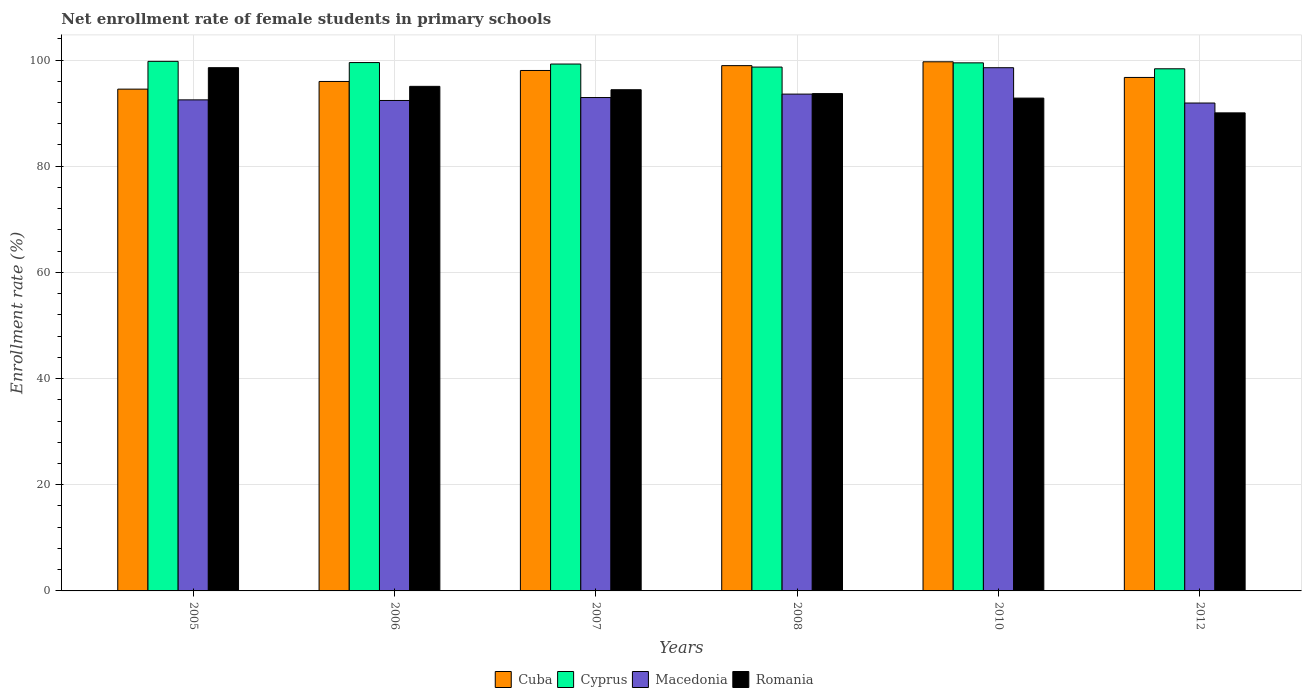How many groups of bars are there?
Offer a terse response. 6. Are the number of bars per tick equal to the number of legend labels?
Your response must be concise. Yes. Are the number of bars on each tick of the X-axis equal?
Your response must be concise. Yes. How many bars are there on the 4th tick from the right?
Your answer should be compact. 4. What is the net enrollment rate of female students in primary schools in Cuba in 2005?
Give a very brief answer. 94.51. Across all years, what is the maximum net enrollment rate of female students in primary schools in Macedonia?
Make the answer very short. 98.55. Across all years, what is the minimum net enrollment rate of female students in primary schools in Macedonia?
Ensure brevity in your answer.  91.9. In which year was the net enrollment rate of female students in primary schools in Macedonia minimum?
Your answer should be compact. 2012. What is the total net enrollment rate of female students in primary schools in Cyprus in the graph?
Offer a terse response. 594.99. What is the difference between the net enrollment rate of female students in primary schools in Macedonia in 2006 and that in 2008?
Your answer should be very brief. -1.2. What is the difference between the net enrollment rate of female students in primary schools in Cyprus in 2008 and the net enrollment rate of female students in primary schools in Romania in 2006?
Provide a short and direct response. 3.63. What is the average net enrollment rate of female students in primary schools in Cyprus per year?
Ensure brevity in your answer.  99.16. In the year 2007, what is the difference between the net enrollment rate of female students in primary schools in Romania and net enrollment rate of female students in primary schools in Cyprus?
Your answer should be compact. -4.84. What is the ratio of the net enrollment rate of female students in primary schools in Cuba in 2006 to that in 2007?
Ensure brevity in your answer.  0.98. Is the net enrollment rate of female students in primary schools in Macedonia in 2005 less than that in 2006?
Give a very brief answer. No. What is the difference between the highest and the second highest net enrollment rate of female students in primary schools in Macedonia?
Your answer should be very brief. 4.97. What is the difference between the highest and the lowest net enrollment rate of female students in primary schools in Cyprus?
Your answer should be very brief. 1.4. Is it the case that in every year, the sum of the net enrollment rate of female students in primary schools in Cyprus and net enrollment rate of female students in primary schools in Romania is greater than the sum of net enrollment rate of female students in primary schools in Cuba and net enrollment rate of female students in primary schools in Macedonia?
Make the answer very short. No. What does the 4th bar from the left in 2012 represents?
Make the answer very short. Romania. What does the 1st bar from the right in 2012 represents?
Provide a short and direct response. Romania. Is it the case that in every year, the sum of the net enrollment rate of female students in primary schools in Cyprus and net enrollment rate of female students in primary schools in Cuba is greater than the net enrollment rate of female students in primary schools in Romania?
Provide a succinct answer. Yes. How many bars are there?
Give a very brief answer. 24. Does the graph contain any zero values?
Your answer should be very brief. No. Does the graph contain grids?
Your answer should be compact. Yes. How are the legend labels stacked?
Your answer should be very brief. Horizontal. What is the title of the graph?
Offer a terse response. Net enrollment rate of female students in primary schools. What is the label or title of the X-axis?
Offer a terse response. Years. What is the label or title of the Y-axis?
Make the answer very short. Enrollment rate (%). What is the Enrollment rate (%) in Cuba in 2005?
Your answer should be very brief. 94.51. What is the Enrollment rate (%) in Cyprus in 2005?
Your response must be concise. 99.75. What is the Enrollment rate (%) in Macedonia in 2005?
Offer a very short reply. 92.49. What is the Enrollment rate (%) in Romania in 2005?
Offer a very short reply. 98.55. What is the Enrollment rate (%) in Cuba in 2006?
Your response must be concise. 95.96. What is the Enrollment rate (%) in Cyprus in 2006?
Give a very brief answer. 99.52. What is the Enrollment rate (%) in Macedonia in 2006?
Provide a short and direct response. 92.38. What is the Enrollment rate (%) of Romania in 2006?
Your answer should be compact. 95.04. What is the Enrollment rate (%) of Cuba in 2007?
Make the answer very short. 98.03. What is the Enrollment rate (%) of Cyprus in 2007?
Provide a succinct answer. 99.24. What is the Enrollment rate (%) in Macedonia in 2007?
Give a very brief answer. 92.93. What is the Enrollment rate (%) of Romania in 2007?
Ensure brevity in your answer.  94.4. What is the Enrollment rate (%) in Cuba in 2008?
Provide a succinct answer. 98.94. What is the Enrollment rate (%) of Cyprus in 2008?
Your answer should be very brief. 98.67. What is the Enrollment rate (%) in Macedonia in 2008?
Provide a succinct answer. 93.58. What is the Enrollment rate (%) in Romania in 2008?
Your answer should be very brief. 93.67. What is the Enrollment rate (%) in Cuba in 2010?
Your response must be concise. 99.66. What is the Enrollment rate (%) in Cyprus in 2010?
Ensure brevity in your answer.  99.46. What is the Enrollment rate (%) in Macedonia in 2010?
Provide a succinct answer. 98.55. What is the Enrollment rate (%) of Romania in 2010?
Provide a short and direct response. 92.82. What is the Enrollment rate (%) in Cuba in 2012?
Provide a short and direct response. 96.72. What is the Enrollment rate (%) of Cyprus in 2012?
Keep it short and to the point. 98.35. What is the Enrollment rate (%) in Macedonia in 2012?
Provide a short and direct response. 91.9. What is the Enrollment rate (%) of Romania in 2012?
Keep it short and to the point. 90.04. Across all years, what is the maximum Enrollment rate (%) in Cuba?
Your response must be concise. 99.66. Across all years, what is the maximum Enrollment rate (%) in Cyprus?
Make the answer very short. 99.75. Across all years, what is the maximum Enrollment rate (%) of Macedonia?
Offer a terse response. 98.55. Across all years, what is the maximum Enrollment rate (%) in Romania?
Keep it short and to the point. 98.55. Across all years, what is the minimum Enrollment rate (%) in Cuba?
Make the answer very short. 94.51. Across all years, what is the minimum Enrollment rate (%) in Cyprus?
Keep it short and to the point. 98.35. Across all years, what is the minimum Enrollment rate (%) in Macedonia?
Provide a short and direct response. 91.9. Across all years, what is the minimum Enrollment rate (%) of Romania?
Provide a succinct answer. 90.04. What is the total Enrollment rate (%) in Cuba in the graph?
Ensure brevity in your answer.  583.82. What is the total Enrollment rate (%) in Cyprus in the graph?
Give a very brief answer. 594.99. What is the total Enrollment rate (%) of Macedonia in the graph?
Ensure brevity in your answer.  561.83. What is the total Enrollment rate (%) of Romania in the graph?
Make the answer very short. 564.54. What is the difference between the Enrollment rate (%) of Cuba in 2005 and that in 2006?
Provide a short and direct response. -1.45. What is the difference between the Enrollment rate (%) in Cyprus in 2005 and that in 2006?
Provide a short and direct response. 0.23. What is the difference between the Enrollment rate (%) in Macedonia in 2005 and that in 2006?
Keep it short and to the point. 0.11. What is the difference between the Enrollment rate (%) of Romania in 2005 and that in 2006?
Give a very brief answer. 3.52. What is the difference between the Enrollment rate (%) in Cuba in 2005 and that in 2007?
Offer a very short reply. -3.51. What is the difference between the Enrollment rate (%) in Cyprus in 2005 and that in 2007?
Your answer should be compact. 0.5. What is the difference between the Enrollment rate (%) of Macedonia in 2005 and that in 2007?
Your answer should be compact. -0.44. What is the difference between the Enrollment rate (%) of Romania in 2005 and that in 2007?
Keep it short and to the point. 4.15. What is the difference between the Enrollment rate (%) in Cuba in 2005 and that in 2008?
Your answer should be very brief. -4.43. What is the difference between the Enrollment rate (%) of Cyprus in 2005 and that in 2008?
Provide a short and direct response. 1.08. What is the difference between the Enrollment rate (%) of Macedonia in 2005 and that in 2008?
Give a very brief answer. -1.09. What is the difference between the Enrollment rate (%) of Romania in 2005 and that in 2008?
Provide a short and direct response. 4.88. What is the difference between the Enrollment rate (%) of Cuba in 2005 and that in 2010?
Offer a terse response. -5.15. What is the difference between the Enrollment rate (%) of Cyprus in 2005 and that in 2010?
Your answer should be very brief. 0.28. What is the difference between the Enrollment rate (%) in Macedonia in 2005 and that in 2010?
Offer a very short reply. -6.06. What is the difference between the Enrollment rate (%) in Romania in 2005 and that in 2010?
Provide a short and direct response. 5.73. What is the difference between the Enrollment rate (%) in Cuba in 2005 and that in 2012?
Your answer should be very brief. -2.2. What is the difference between the Enrollment rate (%) in Cyprus in 2005 and that in 2012?
Your answer should be compact. 1.4. What is the difference between the Enrollment rate (%) of Macedonia in 2005 and that in 2012?
Offer a very short reply. 0.59. What is the difference between the Enrollment rate (%) in Romania in 2005 and that in 2012?
Offer a terse response. 8.51. What is the difference between the Enrollment rate (%) in Cuba in 2006 and that in 2007?
Keep it short and to the point. -2.07. What is the difference between the Enrollment rate (%) of Cyprus in 2006 and that in 2007?
Give a very brief answer. 0.28. What is the difference between the Enrollment rate (%) in Macedonia in 2006 and that in 2007?
Provide a short and direct response. -0.55. What is the difference between the Enrollment rate (%) in Romania in 2006 and that in 2007?
Provide a succinct answer. 0.64. What is the difference between the Enrollment rate (%) in Cuba in 2006 and that in 2008?
Provide a succinct answer. -2.98. What is the difference between the Enrollment rate (%) of Cyprus in 2006 and that in 2008?
Your answer should be compact. 0.85. What is the difference between the Enrollment rate (%) in Macedonia in 2006 and that in 2008?
Your response must be concise. -1.2. What is the difference between the Enrollment rate (%) in Romania in 2006 and that in 2008?
Give a very brief answer. 1.36. What is the difference between the Enrollment rate (%) in Cuba in 2006 and that in 2010?
Give a very brief answer. -3.7. What is the difference between the Enrollment rate (%) of Cyprus in 2006 and that in 2010?
Give a very brief answer. 0.05. What is the difference between the Enrollment rate (%) in Macedonia in 2006 and that in 2010?
Offer a very short reply. -6.17. What is the difference between the Enrollment rate (%) in Romania in 2006 and that in 2010?
Give a very brief answer. 2.21. What is the difference between the Enrollment rate (%) in Cuba in 2006 and that in 2012?
Provide a short and direct response. -0.76. What is the difference between the Enrollment rate (%) of Cyprus in 2006 and that in 2012?
Make the answer very short. 1.17. What is the difference between the Enrollment rate (%) in Macedonia in 2006 and that in 2012?
Offer a terse response. 0.48. What is the difference between the Enrollment rate (%) in Romania in 2006 and that in 2012?
Your response must be concise. 5. What is the difference between the Enrollment rate (%) in Cuba in 2007 and that in 2008?
Provide a succinct answer. -0.91. What is the difference between the Enrollment rate (%) in Cyprus in 2007 and that in 2008?
Your answer should be compact. 0.57. What is the difference between the Enrollment rate (%) in Macedonia in 2007 and that in 2008?
Your answer should be compact. -0.65. What is the difference between the Enrollment rate (%) of Romania in 2007 and that in 2008?
Provide a short and direct response. 0.73. What is the difference between the Enrollment rate (%) of Cuba in 2007 and that in 2010?
Provide a short and direct response. -1.64. What is the difference between the Enrollment rate (%) of Cyprus in 2007 and that in 2010?
Provide a short and direct response. -0.22. What is the difference between the Enrollment rate (%) in Macedonia in 2007 and that in 2010?
Provide a short and direct response. -5.62. What is the difference between the Enrollment rate (%) in Romania in 2007 and that in 2010?
Your answer should be compact. 1.58. What is the difference between the Enrollment rate (%) of Cuba in 2007 and that in 2012?
Make the answer very short. 1.31. What is the difference between the Enrollment rate (%) of Cyprus in 2007 and that in 2012?
Ensure brevity in your answer.  0.9. What is the difference between the Enrollment rate (%) of Macedonia in 2007 and that in 2012?
Give a very brief answer. 1.03. What is the difference between the Enrollment rate (%) of Romania in 2007 and that in 2012?
Give a very brief answer. 4.36. What is the difference between the Enrollment rate (%) in Cuba in 2008 and that in 2010?
Offer a terse response. -0.72. What is the difference between the Enrollment rate (%) in Cyprus in 2008 and that in 2010?
Provide a succinct answer. -0.8. What is the difference between the Enrollment rate (%) in Macedonia in 2008 and that in 2010?
Your response must be concise. -4.97. What is the difference between the Enrollment rate (%) of Romania in 2008 and that in 2010?
Your answer should be very brief. 0.85. What is the difference between the Enrollment rate (%) in Cuba in 2008 and that in 2012?
Your response must be concise. 2.22. What is the difference between the Enrollment rate (%) in Cyprus in 2008 and that in 2012?
Provide a short and direct response. 0.32. What is the difference between the Enrollment rate (%) in Macedonia in 2008 and that in 2012?
Offer a very short reply. 1.68. What is the difference between the Enrollment rate (%) of Romania in 2008 and that in 2012?
Ensure brevity in your answer.  3.63. What is the difference between the Enrollment rate (%) of Cuba in 2010 and that in 2012?
Offer a very short reply. 2.95. What is the difference between the Enrollment rate (%) in Cyprus in 2010 and that in 2012?
Your answer should be very brief. 1.12. What is the difference between the Enrollment rate (%) in Macedonia in 2010 and that in 2012?
Provide a short and direct response. 6.65. What is the difference between the Enrollment rate (%) in Romania in 2010 and that in 2012?
Your response must be concise. 2.78. What is the difference between the Enrollment rate (%) of Cuba in 2005 and the Enrollment rate (%) of Cyprus in 2006?
Provide a short and direct response. -5. What is the difference between the Enrollment rate (%) in Cuba in 2005 and the Enrollment rate (%) in Macedonia in 2006?
Offer a very short reply. 2.13. What is the difference between the Enrollment rate (%) of Cuba in 2005 and the Enrollment rate (%) of Romania in 2006?
Your response must be concise. -0.53. What is the difference between the Enrollment rate (%) of Cyprus in 2005 and the Enrollment rate (%) of Macedonia in 2006?
Offer a very short reply. 7.37. What is the difference between the Enrollment rate (%) in Cyprus in 2005 and the Enrollment rate (%) in Romania in 2006?
Offer a terse response. 4.71. What is the difference between the Enrollment rate (%) in Macedonia in 2005 and the Enrollment rate (%) in Romania in 2006?
Your response must be concise. -2.55. What is the difference between the Enrollment rate (%) of Cuba in 2005 and the Enrollment rate (%) of Cyprus in 2007?
Offer a very short reply. -4.73. What is the difference between the Enrollment rate (%) of Cuba in 2005 and the Enrollment rate (%) of Macedonia in 2007?
Your response must be concise. 1.58. What is the difference between the Enrollment rate (%) in Cuba in 2005 and the Enrollment rate (%) in Romania in 2007?
Provide a short and direct response. 0.11. What is the difference between the Enrollment rate (%) in Cyprus in 2005 and the Enrollment rate (%) in Macedonia in 2007?
Give a very brief answer. 6.82. What is the difference between the Enrollment rate (%) in Cyprus in 2005 and the Enrollment rate (%) in Romania in 2007?
Ensure brevity in your answer.  5.35. What is the difference between the Enrollment rate (%) of Macedonia in 2005 and the Enrollment rate (%) of Romania in 2007?
Provide a short and direct response. -1.91. What is the difference between the Enrollment rate (%) of Cuba in 2005 and the Enrollment rate (%) of Cyprus in 2008?
Offer a very short reply. -4.16. What is the difference between the Enrollment rate (%) in Cuba in 2005 and the Enrollment rate (%) in Macedonia in 2008?
Your answer should be very brief. 0.93. What is the difference between the Enrollment rate (%) of Cuba in 2005 and the Enrollment rate (%) of Romania in 2008?
Your answer should be compact. 0.84. What is the difference between the Enrollment rate (%) of Cyprus in 2005 and the Enrollment rate (%) of Macedonia in 2008?
Provide a short and direct response. 6.17. What is the difference between the Enrollment rate (%) in Cyprus in 2005 and the Enrollment rate (%) in Romania in 2008?
Provide a short and direct response. 6.07. What is the difference between the Enrollment rate (%) of Macedonia in 2005 and the Enrollment rate (%) of Romania in 2008?
Ensure brevity in your answer.  -1.18. What is the difference between the Enrollment rate (%) of Cuba in 2005 and the Enrollment rate (%) of Cyprus in 2010?
Make the answer very short. -4.95. What is the difference between the Enrollment rate (%) in Cuba in 2005 and the Enrollment rate (%) in Macedonia in 2010?
Give a very brief answer. -4.04. What is the difference between the Enrollment rate (%) of Cuba in 2005 and the Enrollment rate (%) of Romania in 2010?
Your answer should be compact. 1.69. What is the difference between the Enrollment rate (%) in Cyprus in 2005 and the Enrollment rate (%) in Macedonia in 2010?
Give a very brief answer. 1.2. What is the difference between the Enrollment rate (%) of Cyprus in 2005 and the Enrollment rate (%) of Romania in 2010?
Your answer should be very brief. 6.92. What is the difference between the Enrollment rate (%) of Macedonia in 2005 and the Enrollment rate (%) of Romania in 2010?
Give a very brief answer. -0.33. What is the difference between the Enrollment rate (%) of Cuba in 2005 and the Enrollment rate (%) of Cyprus in 2012?
Provide a short and direct response. -3.83. What is the difference between the Enrollment rate (%) in Cuba in 2005 and the Enrollment rate (%) in Macedonia in 2012?
Make the answer very short. 2.62. What is the difference between the Enrollment rate (%) of Cuba in 2005 and the Enrollment rate (%) of Romania in 2012?
Keep it short and to the point. 4.47. What is the difference between the Enrollment rate (%) of Cyprus in 2005 and the Enrollment rate (%) of Macedonia in 2012?
Make the answer very short. 7.85. What is the difference between the Enrollment rate (%) of Cyprus in 2005 and the Enrollment rate (%) of Romania in 2012?
Give a very brief answer. 9.7. What is the difference between the Enrollment rate (%) of Macedonia in 2005 and the Enrollment rate (%) of Romania in 2012?
Give a very brief answer. 2.45. What is the difference between the Enrollment rate (%) in Cuba in 2006 and the Enrollment rate (%) in Cyprus in 2007?
Provide a succinct answer. -3.28. What is the difference between the Enrollment rate (%) of Cuba in 2006 and the Enrollment rate (%) of Macedonia in 2007?
Your answer should be very brief. 3.03. What is the difference between the Enrollment rate (%) of Cuba in 2006 and the Enrollment rate (%) of Romania in 2007?
Your answer should be compact. 1.56. What is the difference between the Enrollment rate (%) in Cyprus in 2006 and the Enrollment rate (%) in Macedonia in 2007?
Ensure brevity in your answer.  6.59. What is the difference between the Enrollment rate (%) in Cyprus in 2006 and the Enrollment rate (%) in Romania in 2007?
Your answer should be compact. 5.12. What is the difference between the Enrollment rate (%) in Macedonia in 2006 and the Enrollment rate (%) in Romania in 2007?
Your response must be concise. -2.02. What is the difference between the Enrollment rate (%) of Cuba in 2006 and the Enrollment rate (%) of Cyprus in 2008?
Give a very brief answer. -2.71. What is the difference between the Enrollment rate (%) in Cuba in 2006 and the Enrollment rate (%) in Macedonia in 2008?
Your answer should be compact. 2.38. What is the difference between the Enrollment rate (%) in Cuba in 2006 and the Enrollment rate (%) in Romania in 2008?
Make the answer very short. 2.29. What is the difference between the Enrollment rate (%) in Cyprus in 2006 and the Enrollment rate (%) in Macedonia in 2008?
Provide a succinct answer. 5.94. What is the difference between the Enrollment rate (%) in Cyprus in 2006 and the Enrollment rate (%) in Romania in 2008?
Provide a short and direct response. 5.84. What is the difference between the Enrollment rate (%) in Macedonia in 2006 and the Enrollment rate (%) in Romania in 2008?
Keep it short and to the point. -1.3. What is the difference between the Enrollment rate (%) in Cuba in 2006 and the Enrollment rate (%) in Cyprus in 2010?
Provide a short and direct response. -3.51. What is the difference between the Enrollment rate (%) in Cuba in 2006 and the Enrollment rate (%) in Macedonia in 2010?
Offer a very short reply. -2.59. What is the difference between the Enrollment rate (%) in Cuba in 2006 and the Enrollment rate (%) in Romania in 2010?
Give a very brief answer. 3.14. What is the difference between the Enrollment rate (%) in Cyprus in 2006 and the Enrollment rate (%) in Macedonia in 2010?
Your answer should be compact. 0.97. What is the difference between the Enrollment rate (%) in Cyprus in 2006 and the Enrollment rate (%) in Romania in 2010?
Ensure brevity in your answer.  6.69. What is the difference between the Enrollment rate (%) in Macedonia in 2006 and the Enrollment rate (%) in Romania in 2010?
Your answer should be compact. -0.45. What is the difference between the Enrollment rate (%) in Cuba in 2006 and the Enrollment rate (%) in Cyprus in 2012?
Ensure brevity in your answer.  -2.39. What is the difference between the Enrollment rate (%) in Cuba in 2006 and the Enrollment rate (%) in Macedonia in 2012?
Offer a very short reply. 4.06. What is the difference between the Enrollment rate (%) of Cuba in 2006 and the Enrollment rate (%) of Romania in 2012?
Your answer should be very brief. 5.92. What is the difference between the Enrollment rate (%) of Cyprus in 2006 and the Enrollment rate (%) of Macedonia in 2012?
Your answer should be very brief. 7.62. What is the difference between the Enrollment rate (%) in Cyprus in 2006 and the Enrollment rate (%) in Romania in 2012?
Provide a short and direct response. 9.47. What is the difference between the Enrollment rate (%) of Macedonia in 2006 and the Enrollment rate (%) of Romania in 2012?
Ensure brevity in your answer.  2.33. What is the difference between the Enrollment rate (%) in Cuba in 2007 and the Enrollment rate (%) in Cyprus in 2008?
Provide a short and direct response. -0.64. What is the difference between the Enrollment rate (%) of Cuba in 2007 and the Enrollment rate (%) of Macedonia in 2008?
Offer a very short reply. 4.45. What is the difference between the Enrollment rate (%) in Cuba in 2007 and the Enrollment rate (%) in Romania in 2008?
Your answer should be very brief. 4.35. What is the difference between the Enrollment rate (%) in Cyprus in 2007 and the Enrollment rate (%) in Macedonia in 2008?
Your answer should be very brief. 5.66. What is the difference between the Enrollment rate (%) of Cyprus in 2007 and the Enrollment rate (%) of Romania in 2008?
Keep it short and to the point. 5.57. What is the difference between the Enrollment rate (%) in Macedonia in 2007 and the Enrollment rate (%) in Romania in 2008?
Give a very brief answer. -0.74. What is the difference between the Enrollment rate (%) in Cuba in 2007 and the Enrollment rate (%) in Cyprus in 2010?
Your response must be concise. -1.44. What is the difference between the Enrollment rate (%) in Cuba in 2007 and the Enrollment rate (%) in Macedonia in 2010?
Your response must be concise. -0.52. What is the difference between the Enrollment rate (%) of Cuba in 2007 and the Enrollment rate (%) of Romania in 2010?
Offer a terse response. 5.2. What is the difference between the Enrollment rate (%) in Cyprus in 2007 and the Enrollment rate (%) in Macedonia in 2010?
Keep it short and to the point. 0.69. What is the difference between the Enrollment rate (%) of Cyprus in 2007 and the Enrollment rate (%) of Romania in 2010?
Offer a very short reply. 6.42. What is the difference between the Enrollment rate (%) in Macedonia in 2007 and the Enrollment rate (%) in Romania in 2010?
Keep it short and to the point. 0.11. What is the difference between the Enrollment rate (%) of Cuba in 2007 and the Enrollment rate (%) of Cyprus in 2012?
Keep it short and to the point. -0.32. What is the difference between the Enrollment rate (%) of Cuba in 2007 and the Enrollment rate (%) of Macedonia in 2012?
Make the answer very short. 6.13. What is the difference between the Enrollment rate (%) of Cuba in 2007 and the Enrollment rate (%) of Romania in 2012?
Keep it short and to the point. 7.98. What is the difference between the Enrollment rate (%) of Cyprus in 2007 and the Enrollment rate (%) of Macedonia in 2012?
Your answer should be compact. 7.34. What is the difference between the Enrollment rate (%) of Cyprus in 2007 and the Enrollment rate (%) of Romania in 2012?
Provide a short and direct response. 9.2. What is the difference between the Enrollment rate (%) of Macedonia in 2007 and the Enrollment rate (%) of Romania in 2012?
Give a very brief answer. 2.89. What is the difference between the Enrollment rate (%) in Cuba in 2008 and the Enrollment rate (%) in Cyprus in 2010?
Ensure brevity in your answer.  -0.52. What is the difference between the Enrollment rate (%) of Cuba in 2008 and the Enrollment rate (%) of Macedonia in 2010?
Provide a succinct answer. 0.39. What is the difference between the Enrollment rate (%) in Cuba in 2008 and the Enrollment rate (%) in Romania in 2010?
Provide a short and direct response. 6.12. What is the difference between the Enrollment rate (%) in Cyprus in 2008 and the Enrollment rate (%) in Macedonia in 2010?
Your answer should be compact. 0.12. What is the difference between the Enrollment rate (%) of Cyprus in 2008 and the Enrollment rate (%) of Romania in 2010?
Make the answer very short. 5.85. What is the difference between the Enrollment rate (%) of Macedonia in 2008 and the Enrollment rate (%) of Romania in 2010?
Provide a short and direct response. 0.75. What is the difference between the Enrollment rate (%) in Cuba in 2008 and the Enrollment rate (%) in Cyprus in 2012?
Your answer should be very brief. 0.59. What is the difference between the Enrollment rate (%) of Cuba in 2008 and the Enrollment rate (%) of Macedonia in 2012?
Keep it short and to the point. 7.04. What is the difference between the Enrollment rate (%) of Cuba in 2008 and the Enrollment rate (%) of Romania in 2012?
Provide a succinct answer. 8.9. What is the difference between the Enrollment rate (%) in Cyprus in 2008 and the Enrollment rate (%) in Macedonia in 2012?
Provide a short and direct response. 6.77. What is the difference between the Enrollment rate (%) of Cyprus in 2008 and the Enrollment rate (%) of Romania in 2012?
Provide a succinct answer. 8.63. What is the difference between the Enrollment rate (%) in Macedonia in 2008 and the Enrollment rate (%) in Romania in 2012?
Your answer should be very brief. 3.54. What is the difference between the Enrollment rate (%) of Cuba in 2010 and the Enrollment rate (%) of Cyprus in 2012?
Your answer should be very brief. 1.32. What is the difference between the Enrollment rate (%) in Cuba in 2010 and the Enrollment rate (%) in Macedonia in 2012?
Give a very brief answer. 7.77. What is the difference between the Enrollment rate (%) in Cuba in 2010 and the Enrollment rate (%) in Romania in 2012?
Offer a very short reply. 9.62. What is the difference between the Enrollment rate (%) of Cyprus in 2010 and the Enrollment rate (%) of Macedonia in 2012?
Your answer should be very brief. 7.57. What is the difference between the Enrollment rate (%) of Cyprus in 2010 and the Enrollment rate (%) of Romania in 2012?
Keep it short and to the point. 9.42. What is the difference between the Enrollment rate (%) in Macedonia in 2010 and the Enrollment rate (%) in Romania in 2012?
Offer a terse response. 8.5. What is the average Enrollment rate (%) of Cuba per year?
Your response must be concise. 97.3. What is the average Enrollment rate (%) in Cyprus per year?
Offer a very short reply. 99.16. What is the average Enrollment rate (%) in Macedonia per year?
Ensure brevity in your answer.  93.64. What is the average Enrollment rate (%) of Romania per year?
Provide a short and direct response. 94.09. In the year 2005, what is the difference between the Enrollment rate (%) of Cuba and Enrollment rate (%) of Cyprus?
Give a very brief answer. -5.23. In the year 2005, what is the difference between the Enrollment rate (%) of Cuba and Enrollment rate (%) of Macedonia?
Keep it short and to the point. 2.02. In the year 2005, what is the difference between the Enrollment rate (%) of Cuba and Enrollment rate (%) of Romania?
Your answer should be compact. -4.04. In the year 2005, what is the difference between the Enrollment rate (%) of Cyprus and Enrollment rate (%) of Macedonia?
Ensure brevity in your answer.  7.25. In the year 2005, what is the difference between the Enrollment rate (%) in Cyprus and Enrollment rate (%) in Romania?
Offer a terse response. 1.19. In the year 2005, what is the difference between the Enrollment rate (%) of Macedonia and Enrollment rate (%) of Romania?
Your answer should be compact. -6.06. In the year 2006, what is the difference between the Enrollment rate (%) of Cuba and Enrollment rate (%) of Cyprus?
Your answer should be very brief. -3.56. In the year 2006, what is the difference between the Enrollment rate (%) of Cuba and Enrollment rate (%) of Macedonia?
Your response must be concise. 3.58. In the year 2006, what is the difference between the Enrollment rate (%) of Cuba and Enrollment rate (%) of Romania?
Give a very brief answer. 0.92. In the year 2006, what is the difference between the Enrollment rate (%) in Cyprus and Enrollment rate (%) in Macedonia?
Keep it short and to the point. 7.14. In the year 2006, what is the difference between the Enrollment rate (%) of Cyprus and Enrollment rate (%) of Romania?
Your answer should be compact. 4.48. In the year 2006, what is the difference between the Enrollment rate (%) in Macedonia and Enrollment rate (%) in Romania?
Your answer should be compact. -2.66. In the year 2007, what is the difference between the Enrollment rate (%) of Cuba and Enrollment rate (%) of Cyprus?
Your response must be concise. -1.21. In the year 2007, what is the difference between the Enrollment rate (%) of Cuba and Enrollment rate (%) of Macedonia?
Ensure brevity in your answer.  5.1. In the year 2007, what is the difference between the Enrollment rate (%) of Cuba and Enrollment rate (%) of Romania?
Provide a short and direct response. 3.63. In the year 2007, what is the difference between the Enrollment rate (%) in Cyprus and Enrollment rate (%) in Macedonia?
Provide a succinct answer. 6.31. In the year 2007, what is the difference between the Enrollment rate (%) in Cyprus and Enrollment rate (%) in Romania?
Ensure brevity in your answer.  4.84. In the year 2007, what is the difference between the Enrollment rate (%) in Macedonia and Enrollment rate (%) in Romania?
Make the answer very short. -1.47. In the year 2008, what is the difference between the Enrollment rate (%) in Cuba and Enrollment rate (%) in Cyprus?
Your answer should be very brief. 0.27. In the year 2008, what is the difference between the Enrollment rate (%) in Cuba and Enrollment rate (%) in Macedonia?
Your response must be concise. 5.36. In the year 2008, what is the difference between the Enrollment rate (%) of Cuba and Enrollment rate (%) of Romania?
Your response must be concise. 5.27. In the year 2008, what is the difference between the Enrollment rate (%) of Cyprus and Enrollment rate (%) of Macedonia?
Make the answer very short. 5.09. In the year 2008, what is the difference between the Enrollment rate (%) of Cyprus and Enrollment rate (%) of Romania?
Provide a short and direct response. 5. In the year 2008, what is the difference between the Enrollment rate (%) in Macedonia and Enrollment rate (%) in Romania?
Your response must be concise. -0.1. In the year 2010, what is the difference between the Enrollment rate (%) of Cuba and Enrollment rate (%) of Cyprus?
Your response must be concise. 0.2. In the year 2010, what is the difference between the Enrollment rate (%) in Cuba and Enrollment rate (%) in Macedonia?
Provide a short and direct response. 1.12. In the year 2010, what is the difference between the Enrollment rate (%) of Cuba and Enrollment rate (%) of Romania?
Provide a short and direct response. 6.84. In the year 2010, what is the difference between the Enrollment rate (%) in Cyprus and Enrollment rate (%) in Macedonia?
Offer a very short reply. 0.92. In the year 2010, what is the difference between the Enrollment rate (%) in Cyprus and Enrollment rate (%) in Romania?
Your response must be concise. 6.64. In the year 2010, what is the difference between the Enrollment rate (%) in Macedonia and Enrollment rate (%) in Romania?
Your response must be concise. 5.72. In the year 2012, what is the difference between the Enrollment rate (%) in Cuba and Enrollment rate (%) in Cyprus?
Your answer should be compact. -1.63. In the year 2012, what is the difference between the Enrollment rate (%) in Cuba and Enrollment rate (%) in Macedonia?
Your answer should be very brief. 4.82. In the year 2012, what is the difference between the Enrollment rate (%) in Cuba and Enrollment rate (%) in Romania?
Provide a short and direct response. 6.67. In the year 2012, what is the difference between the Enrollment rate (%) of Cyprus and Enrollment rate (%) of Macedonia?
Provide a succinct answer. 6.45. In the year 2012, what is the difference between the Enrollment rate (%) of Cyprus and Enrollment rate (%) of Romania?
Your answer should be very brief. 8.3. In the year 2012, what is the difference between the Enrollment rate (%) of Macedonia and Enrollment rate (%) of Romania?
Offer a terse response. 1.85. What is the ratio of the Enrollment rate (%) in Cuba in 2005 to that in 2006?
Make the answer very short. 0.98. What is the ratio of the Enrollment rate (%) of Cyprus in 2005 to that in 2006?
Provide a short and direct response. 1. What is the ratio of the Enrollment rate (%) in Macedonia in 2005 to that in 2006?
Offer a very short reply. 1. What is the ratio of the Enrollment rate (%) in Romania in 2005 to that in 2006?
Your answer should be very brief. 1.04. What is the ratio of the Enrollment rate (%) in Cuba in 2005 to that in 2007?
Offer a terse response. 0.96. What is the ratio of the Enrollment rate (%) of Macedonia in 2005 to that in 2007?
Ensure brevity in your answer.  1. What is the ratio of the Enrollment rate (%) of Romania in 2005 to that in 2007?
Your response must be concise. 1.04. What is the ratio of the Enrollment rate (%) in Cuba in 2005 to that in 2008?
Give a very brief answer. 0.96. What is the ratio of the Enrollment rate (%) of Cyprus in 2005 to that in 2008?
Your answer should be compact. 1.01. What is the ratio of the Enrollment rate (%) of Macedonia in 2005 to that in 2008?
Your response must be concise. 0.99. What is the ratio of the Enrollment rate (%) in Romania in 2005 to that in 2008?
Give a very brief answer. 1.05. What is the ratio of the Enrollment rate (%) in Cuba in 2005 to that in 2010?
Your answer should be compact. 0.95. What is the ratio of the Enrollment rate (%) in Cyprus in 2005 to that in 2010?
Give a very brief answer. 1. What is the ratio of the Enrollment rate (%) in Macedonia in 2005 to that in 2010?
Offer a terse response. 0.94. What is the ratio of the Enrollment rate (%) of Romania in 2005 to that in 2010?
Offer a very short reply. 1.06. What is the ratio of the Enrollment rate (%) of Cuba in 2005 to that in 2012?
Provide a succinct answer. 0.98. What is the ratio of the Enrollment rate (%) in Cyprus in 2005 to that in 2012?
Your answer should be very brief. 1.01. What is the ratio of the Enrollment rate (%) in Romania in 2005 to that in 2012?
Keep it short and to the point. 1.09. What is the ratio of the Enrollment rate (%) of Cuba in 2006 to that in 2007?
Give a very brief answer. 0.98. What is the ratio of the Enrollment rate (%) of Cyprus in 2006 to that in 2007?
Your response must be concise. 1. What is the ratio of the Enrollment rate (%) in Macedonia in 2006 to that in 2007?
Offer a terse response. 0.99. What is the ratio of the Enrollment rate (%) of Romania in 2006 to that in 2007?
Ensure brevity in your answer.  1.01. What is the ratio of the Enrollment rate (%) of Cuba in 2006 to that in 2008?
Your response must be concise. 0.97. What is the ratio of the Enrollment rate (%) of Cyprus in 2006 to that in 2008?
Give a very brief answer. 1.01. What is the ratio of the Enrollment rate (%) in Macedonia in 2006 to that in 2008?
Offer a very short reply. 0.99. What is the ratio of the Enrollment rate (%) in Romania in 2006 to that in 2008?
Your answer should be very brief. 1.01. What is the ratio of the Enrollment rate (%) in Cuba in 2006 to that in 2010?
Give a very brief answer. 0.96. What is the ratio of the Enrollment rate (%) of Cyprus in 2006 to that in 2010?
Your answer should be very brief. 1. What is the ratio of the Enrollment rate (%) in Macedonia in 2006 to that in 2010?
Your answer should be compact. 0.94. What is the ratio of the Enrollment rate (%) in Romania in 2006 to that in 2010?
Make the answer very short. 1.02. What is the ratio of the Enrollment rate (%) of Cuba in 2006 to that in 2012?
Ensure brevity in your answer.  0.99. What is the ratio of the Enrollment rate (%) in Cyprus in 2006 to that in 2012?
Your answer should be very brief. 1.01. What is the ratio of the Enrollment rate (%) of Romania in 2006 to that in 2012?
Make the answer very short. 1.06. What is the ratio of the Enrollment rate (%) in Cyprus in 2007 to that in 2008?
Give a very brief answer. 1.01. What is the ratio of the Enrollment rate (%) of Macedonia in 2007 to that in 2008?
Offer a very short reply. 0.99. What is the ratio of the Enrollment rate (%) of Romania in 2007 to that in 2008?
Make the answer very short. 1.01. What is the ratio of the Enrollment rate (%) in Cuba in 2007 to that in 2010?
Give a very brief answer. 0.98. What is the ratio of the Enrollment rate (%) in Cyprus in 2007 to that in 2010?
Provide a short and direct response. 1. What is the ratio of the Enrollment rate (%) of Macedonia in 2007 to that in 2010?
Provide a succinct answer. 0.94. What is the ratio of the Enrollment rate (%) in Romania in 2007 to that in 2010?
Offer a terse response. 1.02. What is the ratio of the Enrollment rate (%) of Cuba in 2007 to that in 2012?
Provide a succinct answer. 1.01. What is the ratio of the Enrollment rate (%) of Cyprus in 2007 to that in 2012?
Ensure brevity in your answer.  1.01. What is the ratio of the Enrollment rate (%) of Macedonia in 2007 to that in 2012?
Ensure brevity in your answer.  1.01. What is the ratio of the Enrollment rate (%) of Romania in 2007 to that in 2012?
Ensure brevity in your answer.  1.05. What is the ratio of the Enrollment rate (%) of Cuba in 2008 to that in 2010?
Provide a short and direct response. 0.99. What is the ratio of the Enrollment rate (%) of Cyprus in 2008 to that in 2010?
Your answer should be very brief. 0.99. What is the ratio of the Enrollment rate (%) in Macedonia in 2008 to that in 2010?
Ensure brevity in your answer.  0.95. What is the ratio of the Enrollment rate (%) of Romania in 2008 to that in 2010?
Your answer should be compact. 1.01. What is the ratio of the Enrollment rate (%) of Cyprus in 2008 to that in 2012?
Offer a terse response. 1. What is the ratio of the Enrollment rate (%) of Macedonia in 2008 to that in 2012?
Your answer should be compact. 1.02. What is the ratio of the Enrollment rate (%) in Romania in 2008 to that in 2012?
Offer a very short reply. 1.04. What is the ratio of the Enrollment rate (%) in Cuba in 2010 to that in 2012?
Your response must be concise. 1.03. What is the ratio of the Enrollment rate (%) in Cyprus in 2010 to that in 2012?
Give a very brief answer. 1.01. What is the ratio of the Enrollment rate (%) of Macedonia in 2010 to that in 2012?
Provide a short and direct response. 1.07. What is the ratio of the Enrollment rate (%) in Romania in 2010 to that in 2012?
Provide a short and direct response. 1.03. What is the difference between the highest and the second highest Enrollment rate (%) in Cuba?
Offer a very short reply. 0.72. What is the difference between the highest and the second highest Enrollment rate (%) of Cyprus?
Your answer should be compact. 0.23. What is the difference between the highest and the second highest Enrollment rate (%) in Macedonia?
Give a very brief answer. 4.97. What is the difference between the highest and the second highest Enrollment rate (%) in Romania?
Your answer should be very brief. 3.52. What is the difference between the highest and the lowest Enrollment rate (%) of Cuba?
Keep it short and to the point. 5.15. What is the difference between the highest and the lowest Enrollment rate (%) in Cyprus?
Provide a succinct answer. 1.4. What is the difference between the highest and the lowest Enrollment rate (%) of Macedonia?
Your answer should be compact. 6.65. What is the difference between the highest and the lowest Enrollment rate (%) in Romania?
Provide a short and direct response. 8.51. 